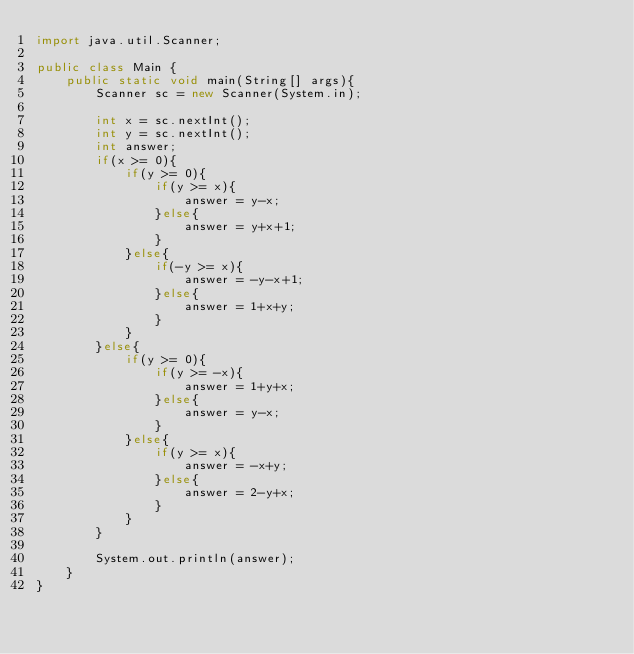<code> <loc_0><loc_0><loc_500><loc_500><_Java_>import java.util.Scanner;

public class Main {
	public static void main(String[] args){
		Scanner sc = new Scanner(System.in);

		int x = sc.nextInt();
		int y = sc.nextInt();
		int answer;
		if(x >= 0){
			if(y >= 0){
				if(y >= x){
					answer = y-x;
				}else{
					answer = y+x+1;
				}
			}else{
				if(-y >= x){
					answer = -y-x+1;
				}else{
					answer = 1+x+y;
				}
			}
		}else{
			if(y >= 0){
				if(y >= -x){
					answer = 1+y+x;
				}else{
					answer = y-x;
				}
			}else{
				if(y >= x){
					answer = -x+y;
				}else{
					answer = 2-y+x;
				}
			}
		}

		System.out.println(answer);
	}
}
</code> 